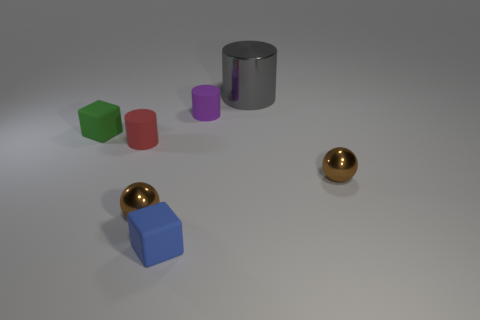Are there an equal number of tiny brown balls that are right of the purple matte cylinder and tiny green rubber cubes behind the big gray metal thing?
Your answer should be compact. No. How many brown metal cylinders are there?
Make the answer very short. 0. Are there more large metallic objects behind the red matte object than purple rubber blocks?
Your response must be concise. Yes. There is a cylinder in front of the small green rubber block; what is it made of?
Your answer should be very brief. Rubber. What color is the other tiny matte thing that is the same shape as the purple matte thing?
Offer a very short reply. Red. How many small objects are the same color as the metal cylinder?
Provide a short and direct response. 0. There is a block in front of the red cylinder; is it the same size as the matte cylinder to the right of the red cylinder?
Ensure brevity in your answer.  Yes. Is the size of the gray metal cylinder the same as the metallic sphere on the left side of the gray cylinder?
Keep it short and to the point. No. What size is the red object?
Provide a succinct answer. Small. What is the color of the tiny cylinder that is the same material as the small purple thing?
Provide a short and direct response. Red. 